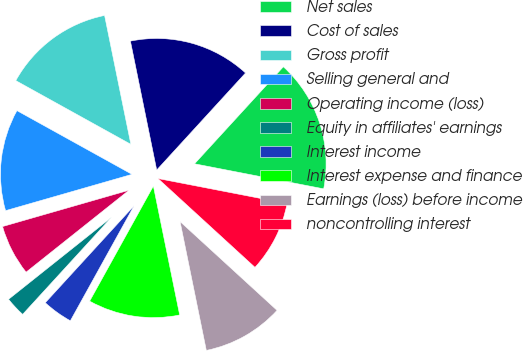Convert chart to OTSL. <chart><loc_0><loc_0><loc_500><loc_500><pie_chart><fcel>Net sales<fcel>Cost of sales<fcel>Gross profit<fcel>Selling general and<fcel>Operating income (loss)<fcel>Equity in affiliates' earnings<fcel>Interest income<fcel>Interest expense and finance<fcel>Earnings (loss) before income<fcel>noncontrolling interest<nl><fcel>16.25%<fcel>15.0%<fcel>13.75%<fcel>12.5%<fcel>6.25%<fcel>2.5%<fcel>3.75%<fcel>11.25%<fcel>10.0%<fcel>8.75%<nl></chart> 